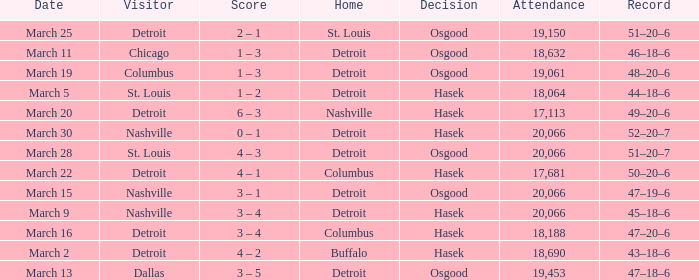Could you help me parse every detail presented in this table? {'header': ['Date', 'Visitor', 'Score', 'Home', 'Decision', 'Attendance', 'Record'], 'rows': [['March 25', 'Detroit', '2 – 1', 'St. Louis', 'Osgood', '19,150', '51–20–6'], ['March 11', 'Chicago', '1 – 3', 'Detroit', 'Osgood', '18,632', '46–18–6'], ['March 19', 'Columbus', '1 – 3', 'Detroit', 'Osgood', '19,061', '48–20–6'], ['March 5', 'St. Louis', '1 – 2', 'Detroit', 'Hasek', '18,064', '44–18–6'], ['March 20', 'Detroit', '6 – 3', 'Nashville', 'Hasek', '17,113', '49–20–6'], ['March 30', 'Nashville', '0 – 1', 'Detroit', 'Hasek', '20,066', '52–20–7'], ['March 28', 'St. Louis', '4 – 3', 'Detroit', 'Osgood', '20,066', '51–20–7'], ['March 22', 'Detroit', '4 – 1', 'Columbus', 'Hasek', '17,681', '50–20–6'], ['March 15', 'Nashville', '3 – 1', 'Detroit', 'Osgood', '20,066', '47–19–6'], ['March 9', 'Nashville', '3 – 4', 'Detroit', 'Hasek', '20,066', '45–18–6'], ['March 16', 'Detroit', '3 – 4', 'Columbus', 'Hasek', '18,188', '47–20–6'], ['March 2', 'Detroit', '4 – 2', 'Buffalo', 'Hasek', '18,690', '43–18–6'], ['March 13', 'Dallas', '3 – 5', 'Detroit', 'Osgood', '19,453', '47–18–6']]} What was the decision of the Red Wings game when they had a record of 45–18–6? Hasek. 